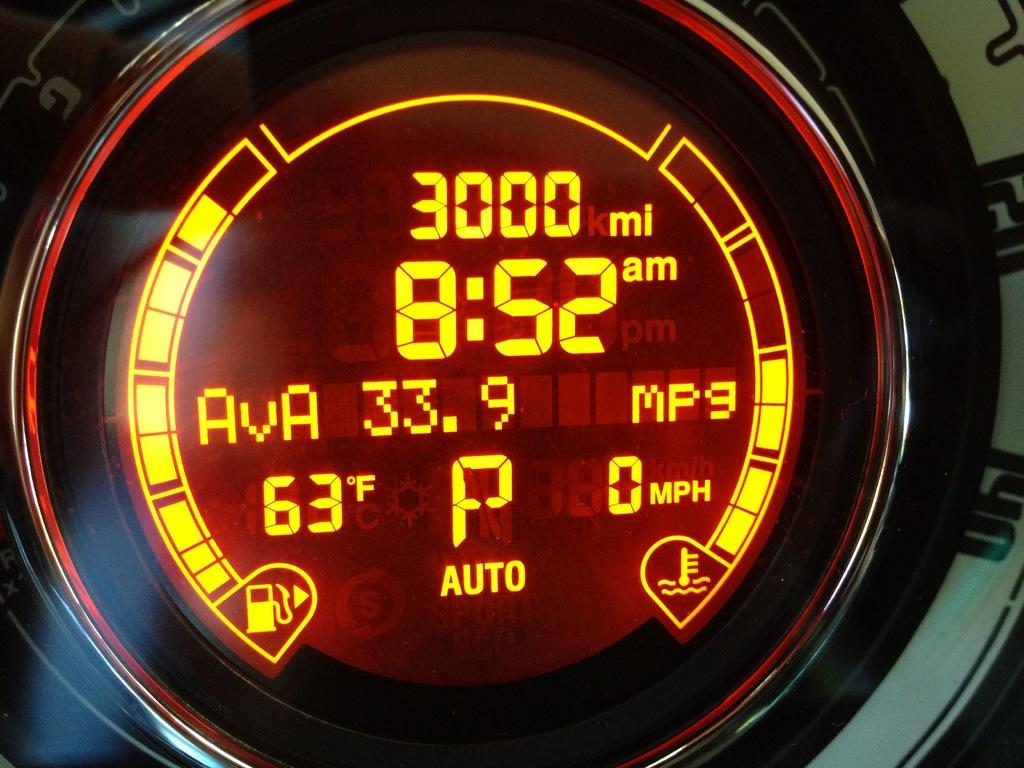<image>
Offer a succinct explanation of the picture presented. A meter that says the time and temperature on the front and says 3000 miles. 